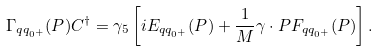<formula> <loc_0><loc_0><loc_500><loc_500>\Gamma _ { q q _ { 0 ^ { + } } } ( P ) C ^ { \dagger } = \gamma _ { 5 } \left [ i E _ { q q _ { 0 ^ { + } } } ( P ) + \frac { 1 } { M } \gamma \cdot P F _ { q q _ { 0 ^ { + } } } ( P ) \right ] .</formula> 